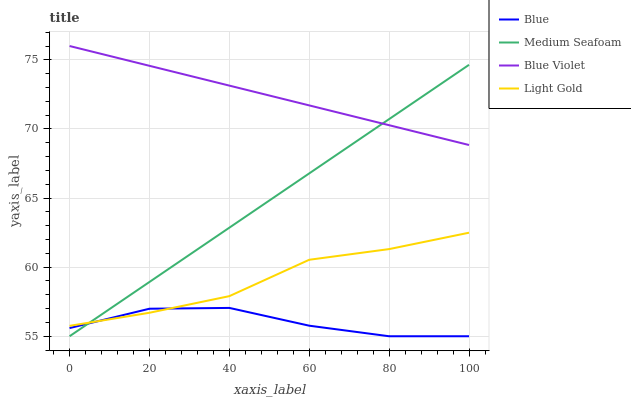Does Blue have the minimum area under the curve?
Answer yes or no. Yes. Does Blue Violet have the maximum area under the curve?
Answer yes or no. Yes. Does Light Gold have the minimum area under the curve?
Answer yes or no. No. Does Light Gold have the maximum area under the curve?
Answer yes or no. No. Is Medium Seafoam the smoothest?
Answer yes or no. Yes. Is Blue the roughest?
Answer yes or no. Yes. Is Light Gold the smoothest?
Answer yes or no. No. Is Light Gold the roughest?
Answer yes or no. No. Does Light Gold have the lowest value?
Answer yes or no. No. Does Blue Violet have the highest value?
Answer yes or no. Yes. Does Light Gold have the highest value?
Answer yes or no. No. Is Blue less than Blue Violet?
Answer yes or no. Yes. Is Blue Violet greater than Light Gold?
Answer yes or no. Yes. Does Blue intersect Blue Violet?
Answer yes or no. No. 